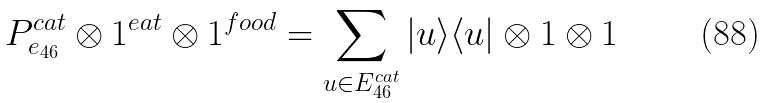<formula> <loc_0><loc_0><loc_500><loc_500>P _ { e _ { 4 6 } } ^ { c a t } \otimes 1 ^ { e a t } \otimes 1 ^ { f o o d } = \sum _ { u \in E _ { 4 6 } ^ { c a t } } | u \rangle \langle u | \otimes 1 \otimes 1</formula> 